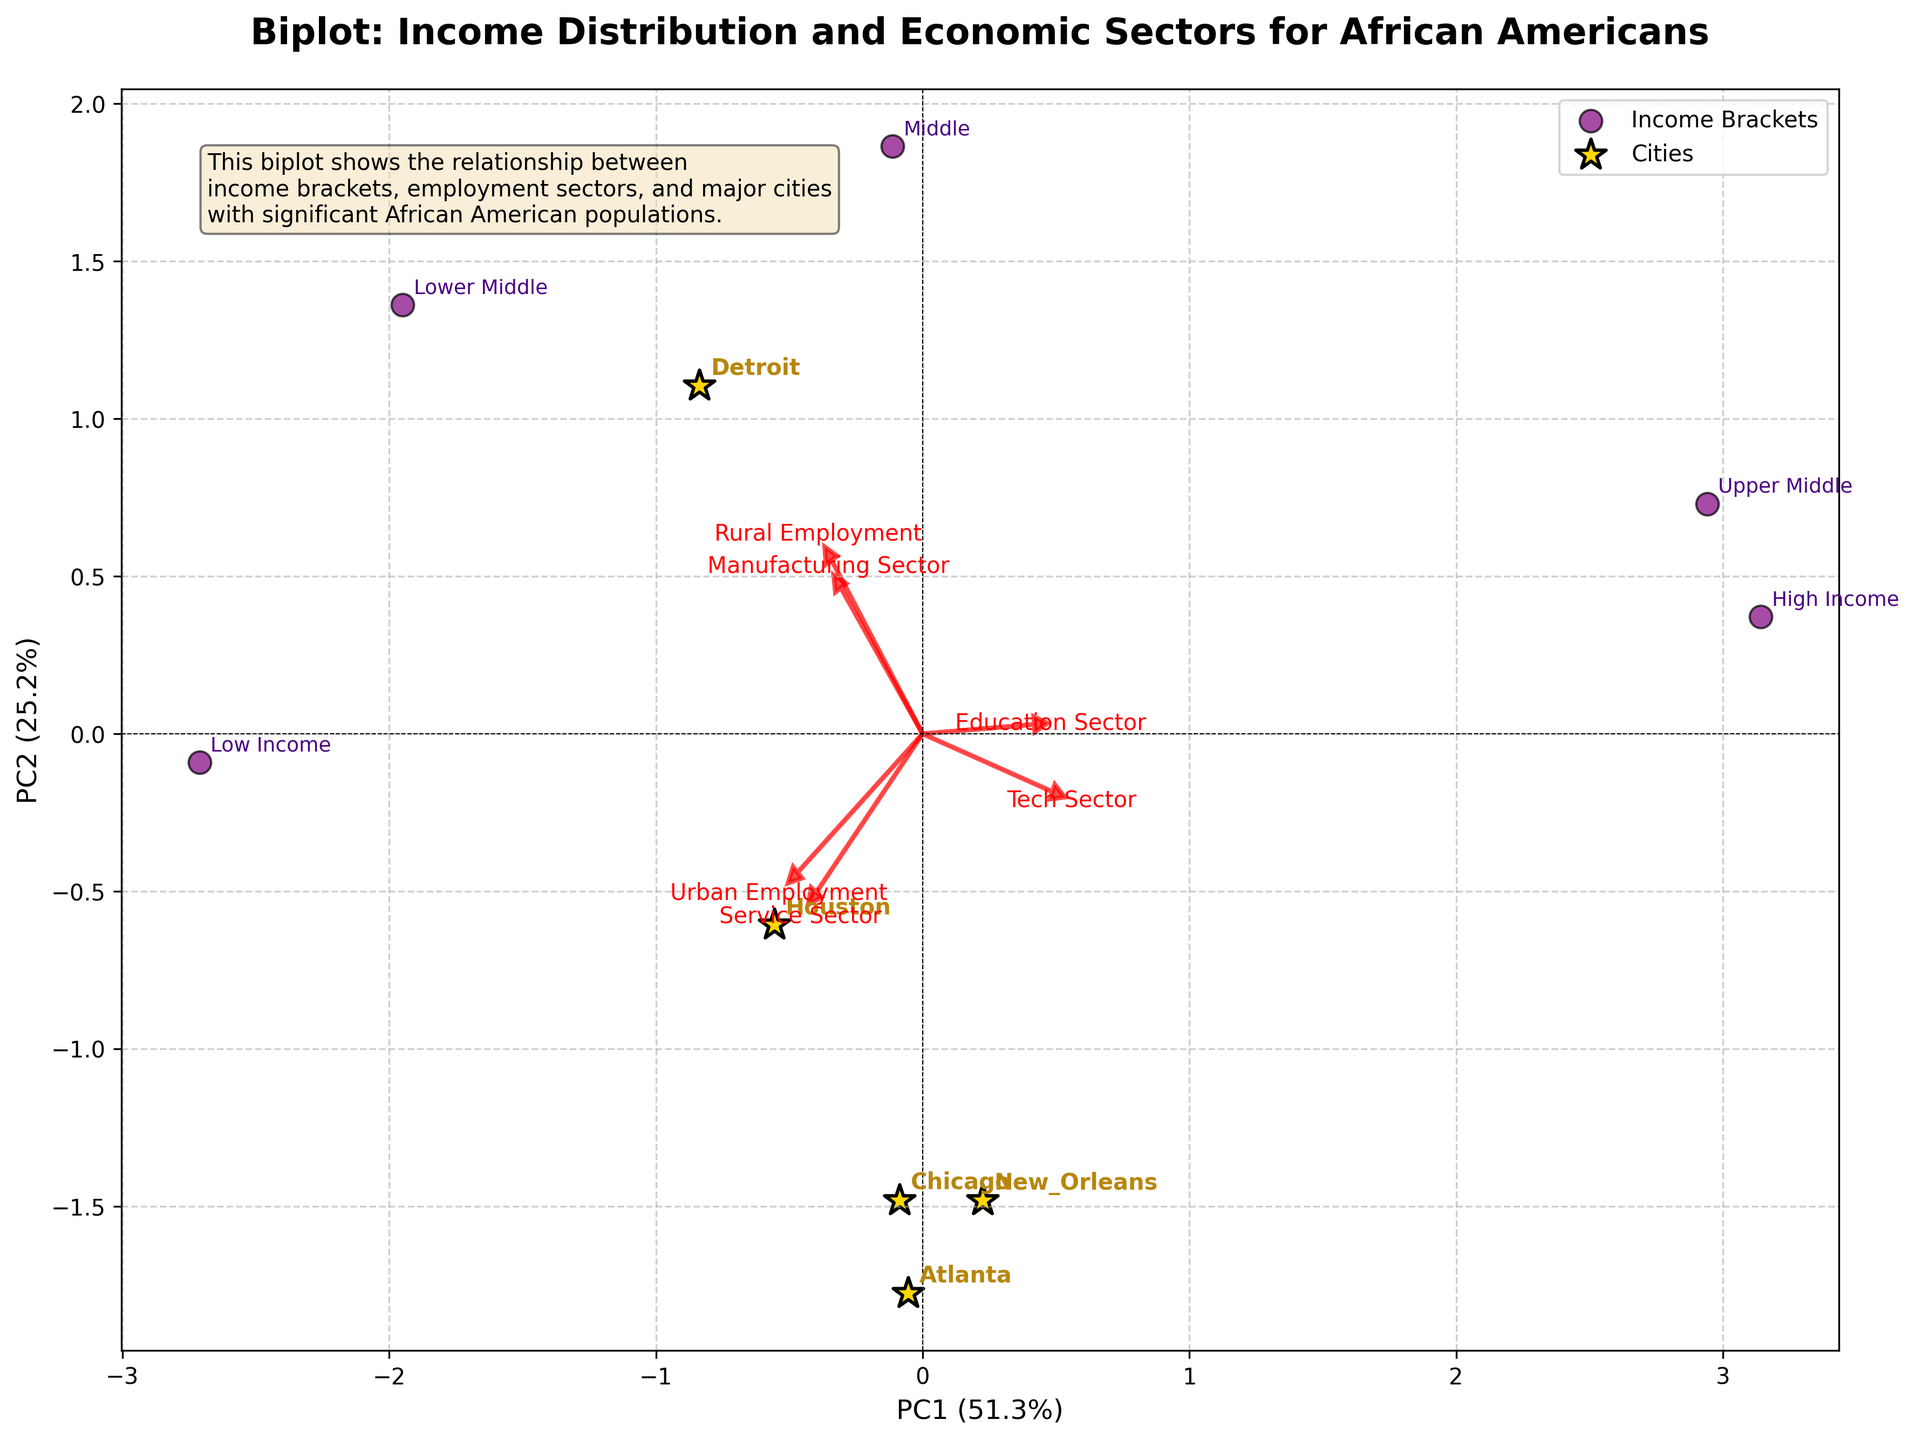what is the title of the biplot? The title of the biplot is located at the top center of the figure. It reads "Biplot: Income Distribution and Economic Sectors for African Americans".
Answer: Biplot: Income Distribution and Economic Sectors for African Americans How many *cities* are represented in the biplot? To determine the number of cities, we look for points marked with a star (*) symbol and the annotations next to them. The cities represented are Atlanta, Chicago, New Orleans, Detroit, and Houston.
Answer: 5 Which *income bracket* has the maximum *urban employment*? Look for the income bracket points labeled and their proximity to the 'Urban Employment' vector arrow. 'Low Income' appears closest, indicating it has the maximum urban employment.
Answer: Low Income Do the data points related to *Detroit* lie in the positive or negative quadrant of PC1? Locate the Detroit data point in the biplot, note its position relative to the vertical axis (PC1). It's in the positive quadrant of PC1.
Answer: Positive Which sector is least associated with *High Income*? Identify the 'High Income' data point and check which sector vector it is furthest from. High Income is far from the 'Service Sector' vector.
Answer: Service Sector What percentage of variance is explained by PC1? Look at the x-axis label, which shows the percentage of variance explained by PC1. It reads "PC1 (X%)".
Answer: ~X.0% Is *Education Sector* more aligned with positive or negative PC2 values? Follow the Education Sector vector from the origin and check its orientation. It points towards positive PC2 values.
Answer: Positive Which cities are located closest to each other in the biplot? Observe the positional clustering of city-labeled points. Chicago and Houston are closest to each other.
Answer: Chicago and Houston Does the *Middle* income bracket align more with the *Tech Sector* or *Manufacturing Sector*? Locate the 'Middle' income bracket data point and check its proximity to the sector vectors. It is closer to the 'Manufacturing Sector' vector.
Answer: Manufacturing Sector 